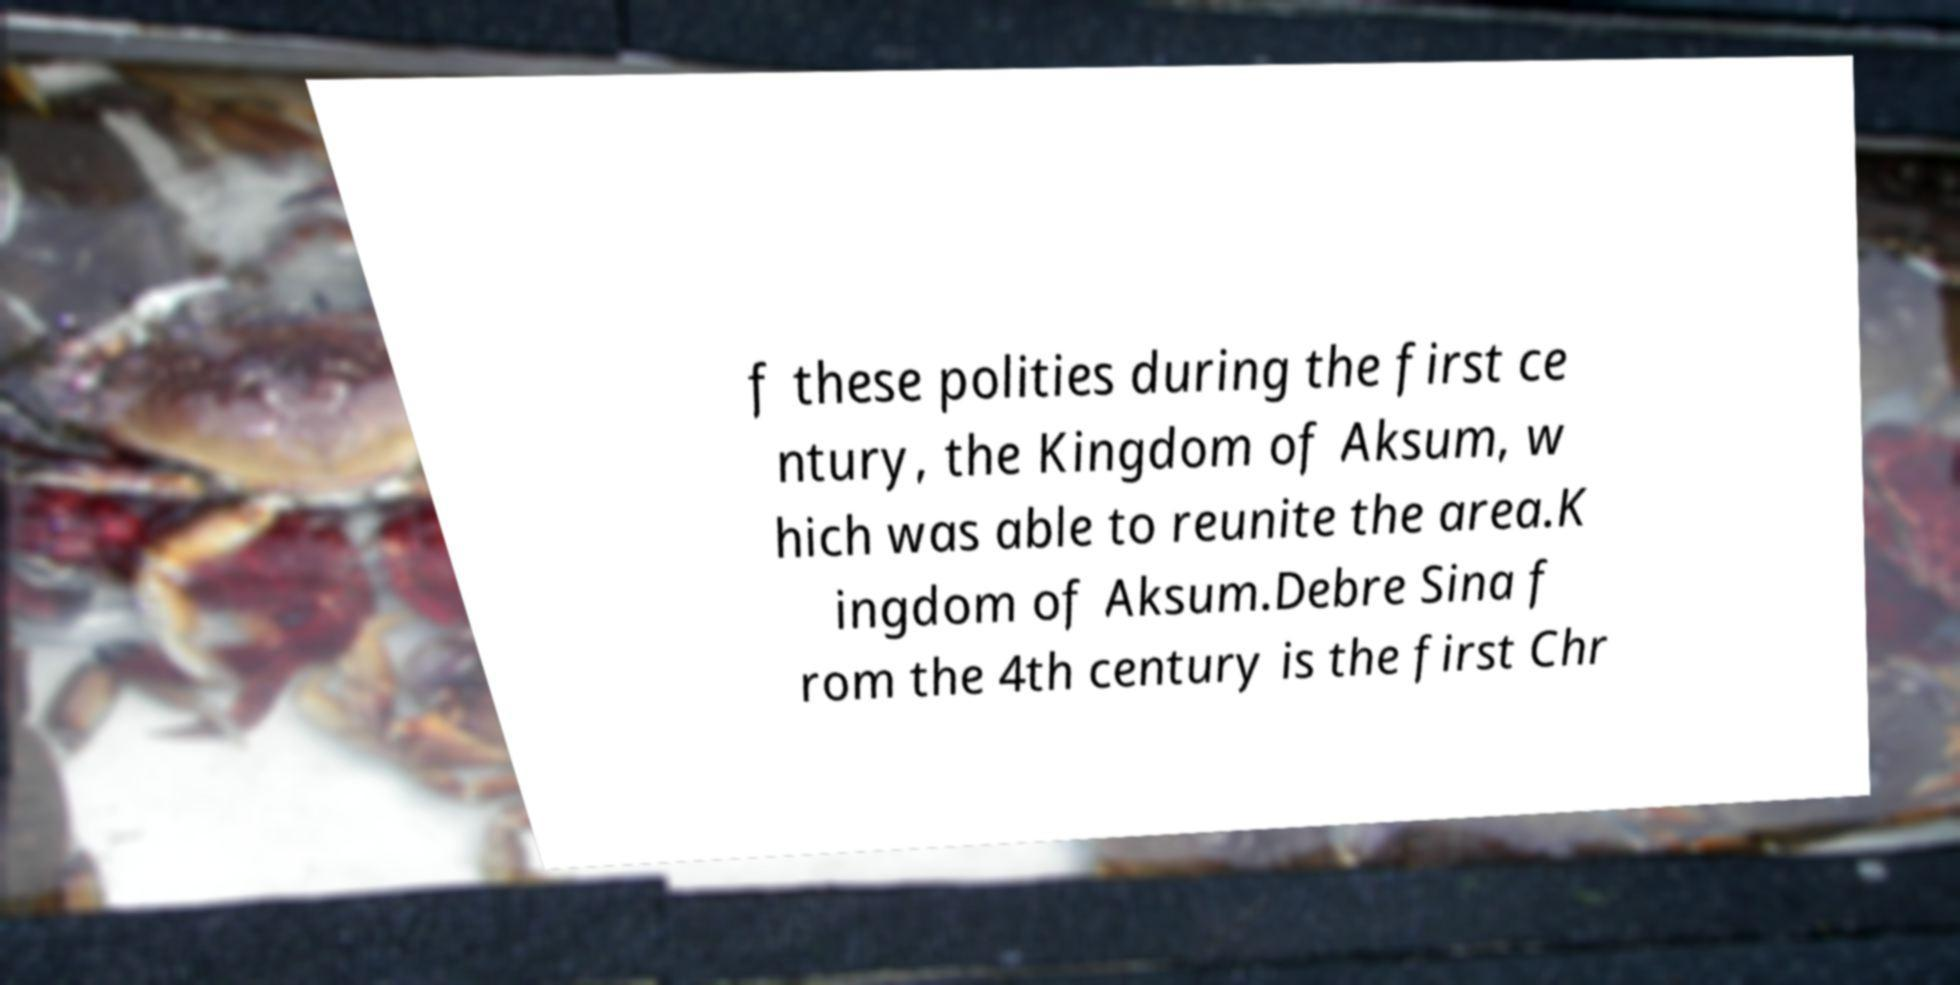Can you read and provide the text displayed in the image?This photo seems to have some interesting text. Can you extract and type it out for me? f these polities during the first ce ntury, the Kingdom of Aksum, w hich was able to reunite the area.K ingdom of Aksum.Debre Sina f rom the 4th century is the first Chr 